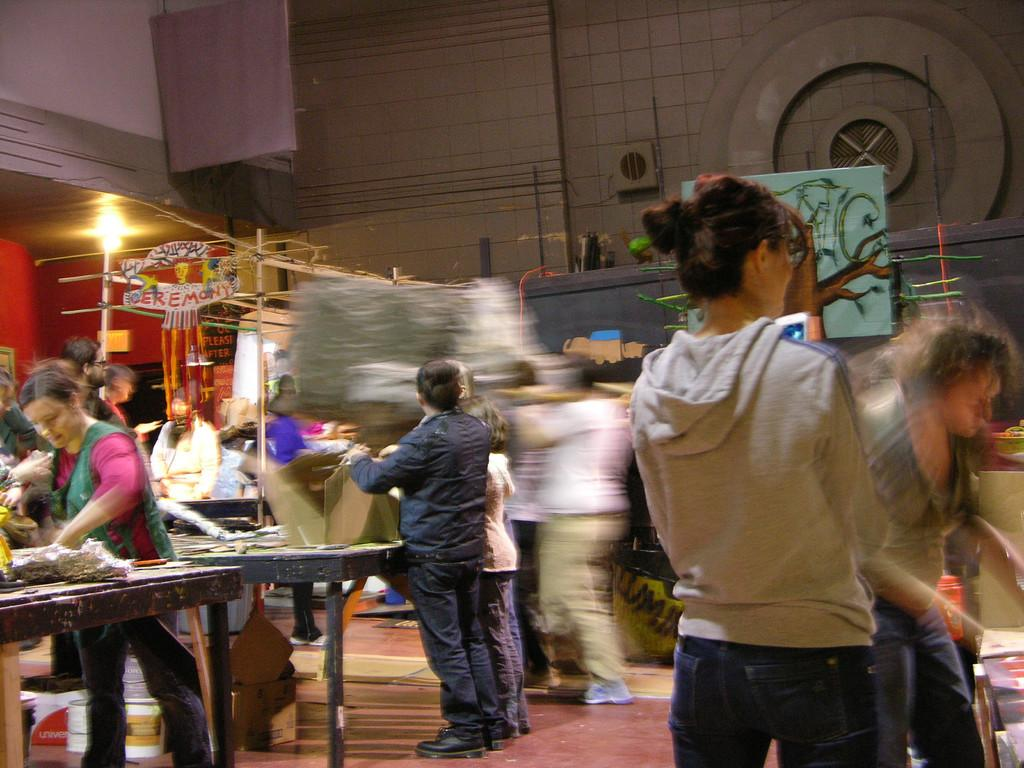What can be seen in the image involving people? There are people standing in the image. What type of furniture is present in the image? There are tables in the image. What is placed on the tables? There are objects on the tables. What can be seen in the background of the image? There is a wall in the background of the image. How is the wall in the background depicted? The wall in the background appears blurred. How many plants are on the tables in the image? There is no information about plants on the tables in the image. 